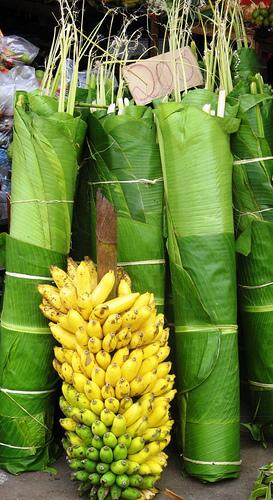How many yellow objects are in the image?
Answer briefly. 1. Why are some of bananas green?
Answer briefly. Not ripe. What is the most prominent color in the picture?
Quick response, please. Green. 